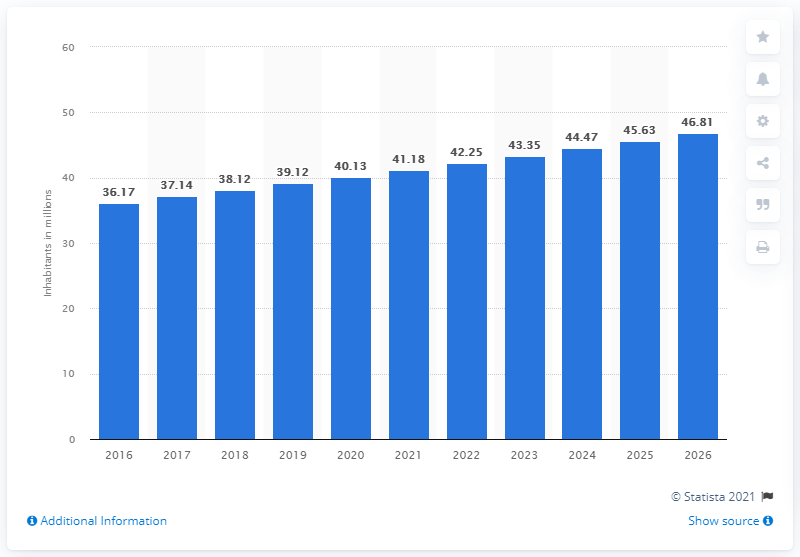What does the bar graph indicate about Iraq's population growth? The bar graph shows a steady increase in the population of Iraq, rising from 36.17 million in 2016 to 46.81 million projected for 2026. It illustrates consistent growth across the depicted years. 